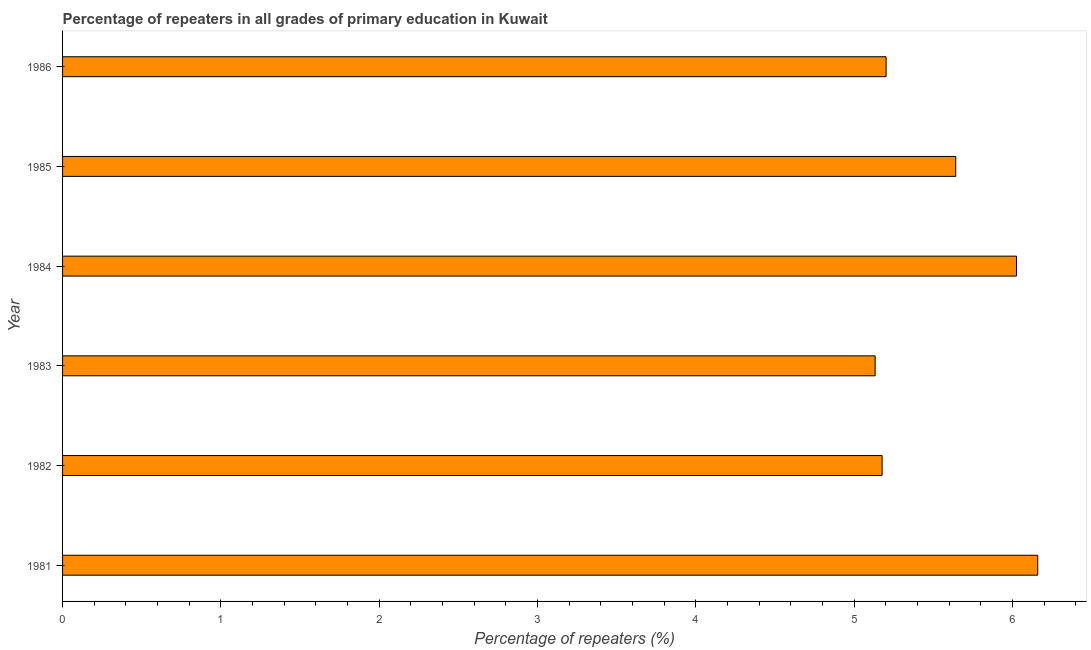Does the graph contain grids?
Offer a very short reply. No. What is the title of the graph?
Give a very brief answer. Percentage of repeaters in all grades of primary education in Kuwait. What is the label or title of the X-axis?
Offer a terse response. Percentage of repeaters (%). What is the label or title of the Y-axis?
Your answer should be compact. Year. What is the percentage of repeaters in primary education in 1983?
Offer a terse response. 5.13. Across all years, what is the maximum percentage of repeaters in primary education?
Offer a very short reply. 6.16. Across all years, what is the minimum percentage of repeaters in primary education?
Offer a terse response. 5.13. In which year was the percentage of repeaters in primary education minimum?
Make the answer very short. 1983. What is the sum of the percentage of repeaters in primary education?
Provide a succinct answer. 33.34. What is the average percentage of repeaters in primary education per year?
Your answer should be compact. 5.56. What is the median percentage of repeaters in primary education?
Your answer should be very brief. 5.42. In how many years, is the percentage of repeaters in primary education greater than 6.2 %?
Keep it short and to the point. 0. Do a majority of the years between 1985 and 1982 (inclusive) have percentage of repeaters in primary education greater than 4.8 %?
Provide a succinct answer. Yes. What is the ratio of the percentage of repeaters in primary education in 1983 to that in 1984?
Provide a short and direct response. 0.85. Is the percentage of repeaters in primary education in 1981 less than that in 1984?
Give a very brief answer. No. Is the difference between the percentage of repeaters in primary education in 1981 and 1982 greater than the difference between any two years?
Your answer should be compact. No. What is the difference between the highest and the second highest percentage of repeaters in primary education?
Offer a very short reply. 0.13. Is the sum of the percentage of repeaters in primary education in 1984 and 1985 greater than the maximum percentage of repeaters in primary education across all years?
Give a very brief answer. Yes. What is the difference between two consecutive major ticks on the X-axis?
Your response must be concise. 1. What is the Percentage of repeaters (%) of 1981?
Offer a very short reply. 6.16. What is the Percentage of repeaters (%) of 1982?
Offer a very short reply. 5.18. What is the Percentage of repeaters (%) of 1983?
Offer a very short reply. 5.13. What is the Percentage of repeaters (%) of 1984?
Your response must be concise. 6.03. What is the Percentage of repeaters (%) in 1985?
Offer a terse response. 5.64. What is the Percentage of repeaters (%) of 1986?
Keep it short and to the point. 5.2. What is the difference between the Percentage of repeaters (%) in 1981 and 1982?
Your answer should be very brief. 0.98. What is the difference between the Percentage of repeaters (%) in 1981 and 1983?
Your answer should be very brief. 1.03. What is the difference between the Percentage of repeaters (%) in 1981 and 1984?
Your response must be concise. 0.13. What is the difference between the Percentage of repeaters (%) in 1981 and 1985?
Your answer should be compact. 0.52. What is the difference between the Percentage of repeaters (%) in 1981 and 1986?
Keep it short and to the point. 0.96. What is the difference between the Percentage of repeaters (%) in 1982 and 1983?
Offer a terse response. 0.04. What is the difference between the Percentage of repeaters (%) in 1982 and 1984?
Offer a terse response. -0.85. What is the difference between the Percentage of repeaters (%) in 1982 and 1985?
Ensure brevity in your answer.  -0.47. What is the difference between the Percentage of repeaters (%) in 1982 and 1986?
Keep it short and to the point. -0.03. What is the difference between the Percentage of repeaters (%) in 1983 and 1984?
Your answer should be very brief. -0.89. What is the difference between the Percentage of repeaters (%) in 1983 and 1985?
Offer a very short reply. -0.51. What is the difference between the Percentage of repeaters (%) in 1983 and 1986?
Keep it short and to the point. -0.07. What is the difference between the Percentage of repeaters (%) in 1984 and 1985?
Provide a succinct answer. 0.38. What is the difference between the Percentage of repeaters (%) in 1984 and 1986?
Your response must be concise. 0.82. What is the difference between the Percentage of repeaters (%) in 1985 and 1986?
Keep it short and to the point. 0.44. What is the ratio of the Percentage of repeaters (%) in 1981 to that in 1982?
Give a very brief answer. 1.19. What is the ratio of the Percentage of repeaters (%) in 1981 to that in 1984?
Your response must be concise. 1.02. What is the ratio of the Percentage of repeaters (%) in 1981 to that in 1985?
Make the answer very short. 1.09. What is the ratio of the Percentage of repeaters (%) in 1981 to that in 1986?
Your answer should be very brief. 1.18. What is the ratio of the Percentage of repeaters (%) in 1982 to that in 1984?
Make the answer very short. 0.86. What is the ratio of the Percentage of repeaters (%) in 1982 to that in 1985?
Your response must be concise. 0.92. What is the ratio of the Percentage of repeaters (%) in 1983 to that in 1984?
Your answer should be compact. 0.85. What is the ratio of the Percentage of repeaters (%) in 1983 to that in 1985?
Your answer should be compact. 0.91. What is the ratio of the Percentage of repeaters (%) in 1984 to that in 1985?
Make the answer very short. 1.07. What is the ratio of the Percentage of repeaters (%) in 1984 to that in 1986?
Your answer should be very brief. 1.16. What is the ratio of the Percentage of repeaters (%) in 1985 to that in 1986?
Make the answer very short. 1.08. 